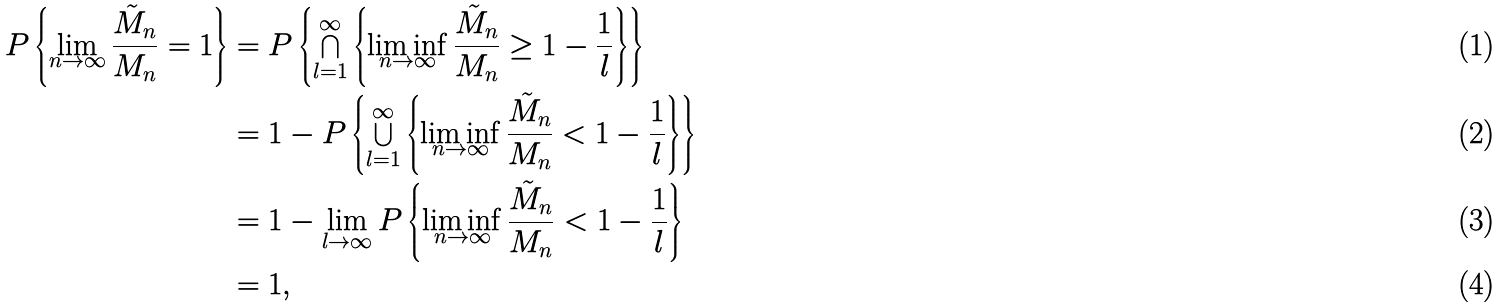Convert formula to latex. <formula><loc_0><loc_0><loc_500><loc_500>P \left \{ \lim _ { n \to \infty } \frac { \tilde { M } _ { n } } { M _ { n } } = 1 \right \} & = P \left \{ \bigcap _ { l = 1 } ^ { \infty } \left \{ \liminf _ { n \to \infty } \frac { \tilde { M } _ { n } } { M _ { n } } \geq 1 - \frac { 1 } { l } \right \} \right \} \\ & = 1 - P \left \{ \bigcup _ { l = 1 } ^ { \infty } \left \{ \liminf _ { n \to \infty } \frac { \tilde { M } _ { n } } { M _ { n } } < 1 - \frac { 1 } { l } \right \} \right \} \\ & = 1 - \lim _ { l \to \infty } P \left \{ \liminf _ { n \to \infty } \frac { \tilde { M } _ { n } } { M _ { n } } < 1 - \frac { 1 } { l } \right \} \\ & = 1 ,</formula> 